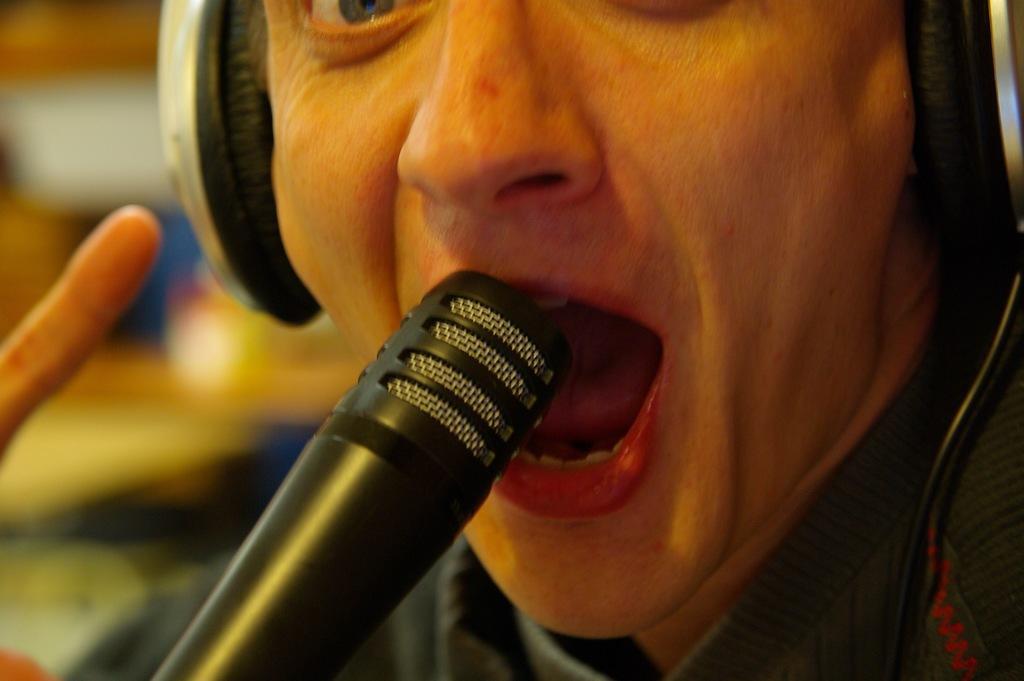Could you give a brief overview of what you see in this image? There is a person wore headset ,in front of this person we can see microphone. On the background it is blur. 